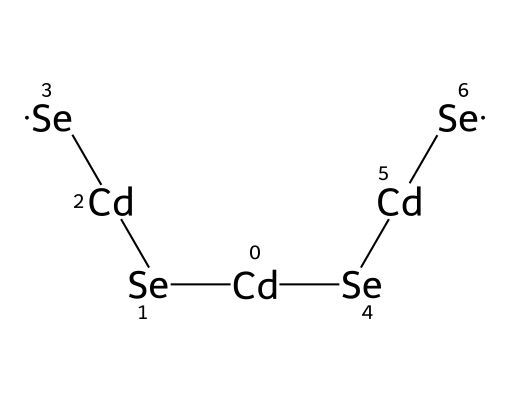What is the primary metal in the structure? The structure shows cadmium atoms represented by [Cd]. Therefore, the primary metal present in the quantum dots is cadmium.
Answer: cadmium How many selenium atoms are present? The structure shows four selenium atoms, denoted by [Se], which can be counted explicitly from the SMILES representation.
Answer: four Is the arrangement linear or branched? By analyzing the connections between the cadmium and selenium atoms in the SMILES notation, we can see that the structure consists of a linear sequence of cadmium and selenium atoms rather than branching.
Answer: linear What is the molecular formula based on the composition? From the SMILES, we have 2 cadmium and 4 selenium atoms, leading to a molecular formula of Cd2Se4.
Answer: Cd2Se4 What type of nanomaterial is described by this structure? The presence of cadmium selenide (CdSe) in the given structure indicates it is a type of quantum dot, which are nanomaterials commonly used in QLED screens.
Answer: quantum dot Explain the significance of the cadmium atoms in quantum dots. Cadmium atoms in this structure of quantum dots play a crucial role in determining the electronic and optical properties, including photoluminescence characteristics used in display technologies.
Answer: electronic and optical properties 